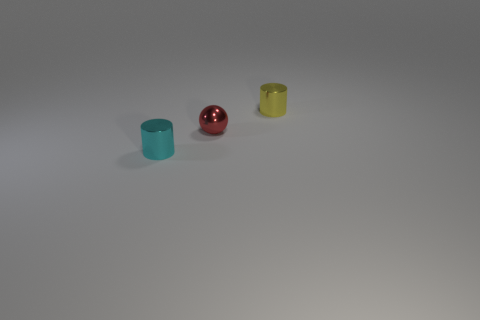The metal thing that is right of the cyan object and in front of the yellow shiny object is what color?
Give a very brief answer. Red. Are the small thing that is in front of the tiny red shiny sphere and the yellow cylinder made of the same material?
Give a very brief answer. Yes. Are there fewer shiny things that are in front of the red metallic thing than large gray shiny cylinders?
Offer a terse response. No. Is there another tiny thing made of the same material as the red thing?
Your response must be concise. Yes. There is a shiny sphere; does it have the same size as the thing to the left of the tiny ball?
Offer a very short reply. Yes. Is there a tiny object of the same color as the metal sphere?
Your answer should be compact. No. Do the tiny yellow cylinder and the ball have the same material?
Keep it short and to the point. Yes. How many small balls are on the left side of the small metallic ball?
Your answer should be very brief. 0. What is the tiny object that is in front of the yellow cylinder and behind the cyan metal cylinder made of?
Keep it short and to the point. Metal. How many green rubber objects are the same size as the cyan object?
Provide a short and direct response. 0. 